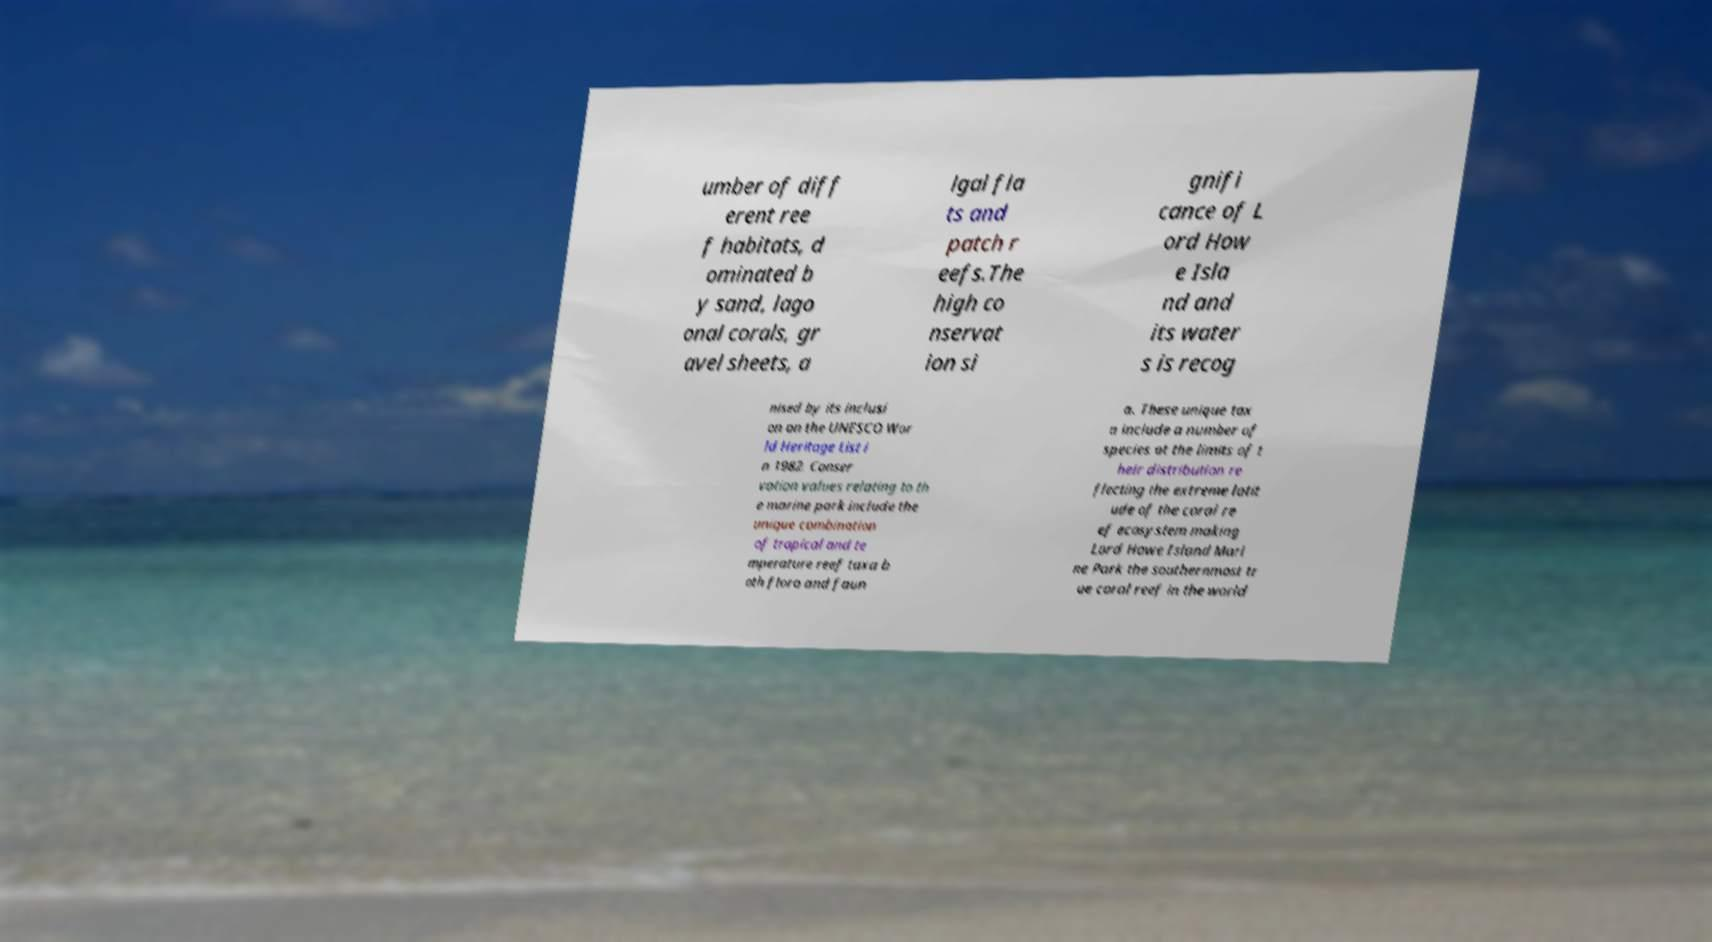Please read and relay the text visible in this image. What does it say? umber of diff erent ree f habitats, d ominated b y sand, lago onal corals, gr avel sheets, a lgal fla ts and patch r eefs.The high co nservat ion si gnifi cance of L ord How e Isla nd and its water s is recog nised by its inclusi on on the UNESCO Wor ld Heritage List i n 1982. Conser vation values relating to th e marine park include the unique combination of tropical and te mperature reef taxa b oth flora and faun a. These unique tax a include a number of species at the limits of t heir distribution re flecting the extreme latit ude of the coral re ef ecosystem making Lord Howe Island Mari ne Park the southernmost tr ue coral reef in the world 